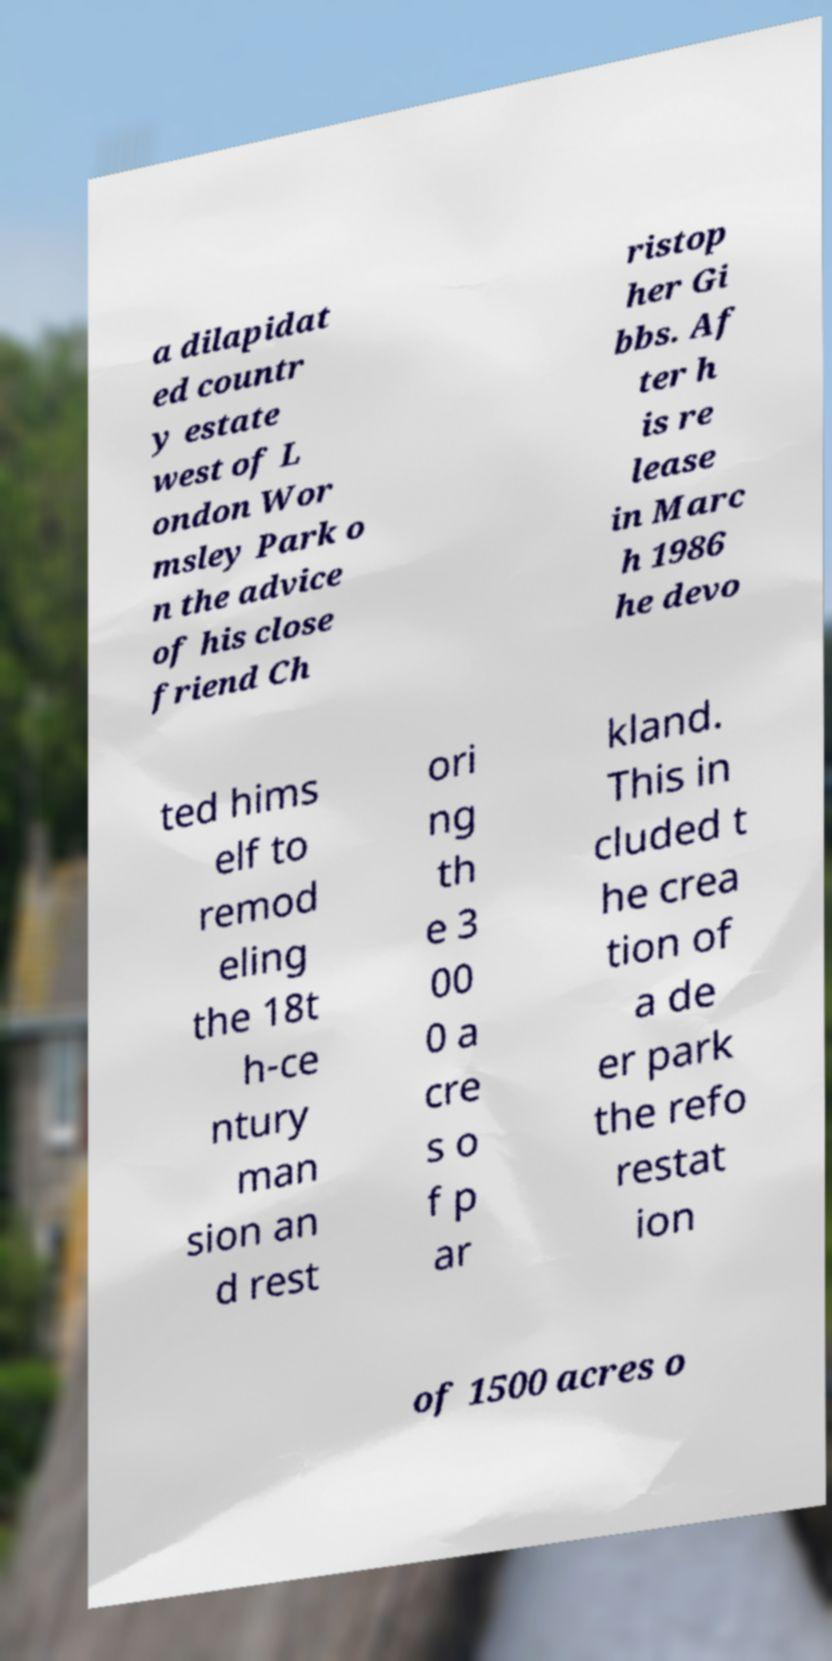Could you extract and type out the text from this image? a dilapidat ed countr y estate west of L ondon Wor msley Park o n the advice of his close friend Ch ristop her Gi bbs. Af ter h is re lease in Marc h 1986 he devo ted hims elf to remod eling the 18t h-ce ntury man sion an d rest ori ng th e 3 00 0 a cre s o f p ar kland. This in cluded t he crea tion of a de er park the refo restat ion of 1500 acres o 